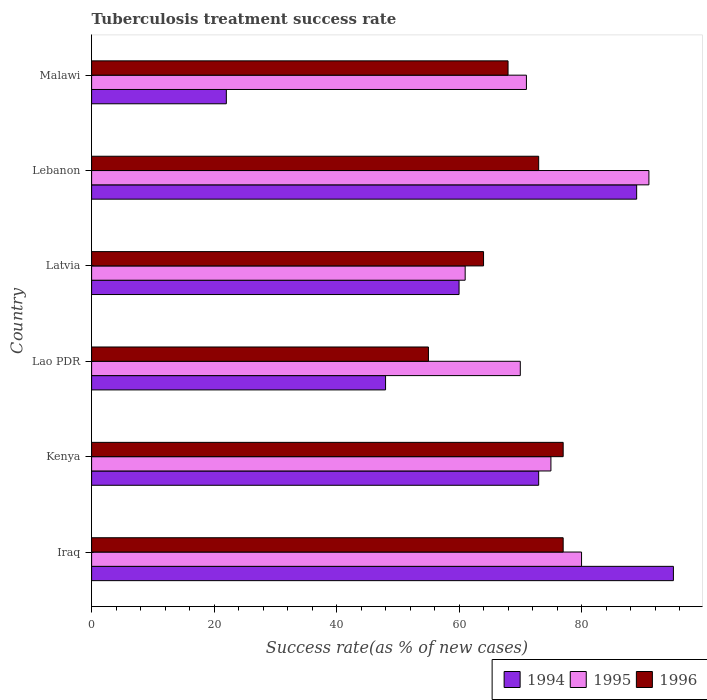How many different coloured bars are there?
Offer a very short reply. 3. How many bars are there on the 5th tick from the top?
Offer a terse response. 3. How many bars are there on the 2nd tick from the bottom?
Ensure brevity in your answer.  3. What is the label of the 5th group of bars from the top?
Give a very brief answer. Kenya. What is the tuberculosis treatment success rate in 1994 in Kenya?
Give a very brief answer. 73. Across all countries, what is the minimum tuberculosis treatment success rate in 1994?
Your answer should be compact. 22. In which country was the tuberculosis treatment success rate in 1995 maximum?
Offer a terse response. Lebanon. In which country was the tuberculosis treatment success rate in 1996 minimum?
Give a very brief answer. Lao PDR. What is the total tuberculosis treatment success rate in 1996 in the graph?
Offer a very short reply. 414. What is the difference between the tuberculosis treatment success rate in 1994 in Kenya and that in Latvia?
Keep it short and to the point. 13. What is the average tuberculosis treatment success rate in 1994 per country?
Your response must be concise. 64.5. What is the ratio of the tuberculosis treatment success rate in 1996 in Iraq to that in Latvia?
Your answer should be very brief. 1.2. In how many countries, is the tuberculosis treatment success rate in 1996 greater than the average tuberculosis treatment success rate in 1996 taken over all countries?
Make the answer very short. 3. Is the sum of the tuberculosis treatment success rate in 1996 in Lao PDR and Malawi greater than the maximum tuberculosis treatment success rate in 1995 across all countries?
Keep it short and to the point. Yes. What does the 2nd bar from the bottom in Kenya represents?
Ensure brevity in your answer.  1995. Is it the case that in every country, the sum of the tuberculosis treatment success rate in 1996 and tuberculosis treatment success rate in 1994 is greater than the tuberculosis treatment success rate in 1995?
Keep it short and to the point. Yes. How many bars are there?
Your answer should be compact. 18. What is the difference between two consecutive major ticks on the X-axis?
Provide a succinct answer. 20. Are the values on the major ticks of X-axis written in scientific E-notation?
Offer a terse response. No. Does the graph contain any zero values?
Provide a succinct answer. No. Where does the legend appear in the graph?
Give a very brief answer. Bottom right. How are the legend labels stacked?
Ensure brevity in your answer.  Horizontal. What is the title of the graph?
Provide a succinct answer. Tuberculosis treatment success rate. Does "1964" appear as one of the legend labels in the graph?
Your answer should be very brief. No. What is the label or title of the X-axis?
Your answer should be compact. Success rate(as % of new cases). What is the Success rate(as % of new cases) of 1995 in Iraq?
Provide a short and direct response. 80. What is the Success rate(as % of new cases) in 1995 in Kenya?
Your answer should be very brief. 75. What is the Success rate(as % of new cases) of 1994 in Lao PDR?
Offer a very short reply. 48. What is the Success rate(as % of new cases) in 1994 in Lebanon?
Give a very brief answer. 89. What is the Success rate(as % of new cases) in 1995 in Lebanon?
Your answer should be very brief. 91. What is the Success rate(as % of new cases) of 1994 in Malawi?
Your response must be concise. 22. What is the Success rate(as % of new cases) in 1995 in Malawi?
Make the answer very short. 71. What is the Success rate(as % of new cases) in 1996 in Malawi?
Keep it short and to the point. 68. Across all countries, what is the maximum Success rate(as % of new cases) of 1995?
Give a very brief answer. 91. Across all countries, what is the minimum Success rate(as % of new cases) in 1994?
Ensure brevity in your answer.  22. Across all countries, what is the minimum Success rate(as % of new cases) of 1996?
Give a very brief answer. 55. What is the total Success rate(as % of new cases) of 1994 in the graph?
Offer a very short reply. 387. What is the total Success rate(as % of new cases) of 1995 in the graph?
Offer a terse response. 448. What is the total Success rate(as % of new cases) in 1996 in the graph?
Keep it short and to the point. 414. What is the difference between the Success rate(as % of new cases) of 1994 in Iraq and that in Lao PDR?
Ensure brevity in your answer.  47. What is the difference between the Success rate(as % of new cases) in 1995 in Iraq and that in Lao PDR?
Your response must be concise. 10. What is the difference between the Success rate(as % of new cases) in 1995 in Iraq and that in Latvia?
Provide a short and direct response. 19. What is the difference between the Success rate(as % of new cases) of 1996 in Iraq and that in Latvia?
Offer a terse response. 13. What is the difference between the Success rate(as % of new cases) in 1994 in Iraq and that in Lebanon?
Your answer should be compact. 6. What is the difference between the Success rate(as % of new cases) in 1995 in Iraq and that in Malawi?
Offer a terse response. 9. What is the difference between the Success rate(as % of new cases) of 1996 in Iraq and that in Malawi?
Your answer should be very brief. 9. What is the difference between the Success rate(as % of new cases) of 1996 in Kenya and that in Lao PDR?
Your answer should be very brief. 22. What is the difference between the Success rate(as % of new cases) of 1994 in Kenya and that in Malawi?
Give a very brief answer. 51. What is the difference between the Success rate(as % of new cases) of 1995 in Kenya and that in Malawi?
Make the answer very short. 4. What is the difference between the Success rate(as % of new cases) of 1996 in Kenya and that in Malawi?
Ensure brevity in your answer.  9. What is the difference between the Success rate(as % of new cases) of 1994 in Lao PDR and that in Lebanon?
Give a very brief answer. -41. What is the difference between the Success rate(as % of new cases) in 1995 in Lao PDR and that in Lebanon?
Ensure brevity in your answer.  -21. What is the difference between the Success rate(as % of new cases) in 1996 in Lao PDR and that in Malawi?
Provide a short and direct response. -13. What is the difference between the Success rate(as % of new cases) of 1994 in Latvia and that in Lebanon?
Provide a short and direct response. -29. What is the difference between the Success rate(as % of new cases) of 1995 in Latvia and that in Lebanon?
Your answer should be very brief. -30. What is the difference between the Success rate(as % of new cases) in 1994 in Latvia and that in Malawi?
Ensure brevity in your answer.  38. What is the difference between the Success rate(as % of new cases) in 1996 in Latvia and that in Malawi?
Make the answer very short. -4. What is the difference between the Success rate(as % of new cases) of 1994 in Lebanon and that in Malawi?
Ensure brevity in your answer.  67. What is the difference between the Success rate(as % of new cases) of 1995 in Iraq and the Success rate(as % of new cases) of 1996 in Kenya?
Your answer should be compact. 3. What is the difference between the Success rate(as % of new cases) in 1994 in Iraq and the Success rate(as % of new cases) in 1995 in Lao PDR?
Offer a terse response. 25. What is the difference between the Success rate(as % of new cases) of 1994 in Iraq and the Success rate(as % of new cases) of 1996 in Lao PDR?
Offer a terse response. 40. What is the difference between the Success rate(as % of new cases) in 1995 in Iraq and the Success rate(as % of new cases) in 1996 in Latvia?
Your response must be concise. 16. What is the difference between the Success rate(as % of new cases) of 1994 in Iraq and the Success rate(as % of new cases) of 1995 in Lebanon?
Your answer should be very brief. 4. What is the difference between the Success rate(as % of new cases) in 1995 in Iraq and the Success rate(as % of new cases) in 1996 in Lebanon?
Give a very brief answer. 7. What is the difference between the Success rate(as % of new cases) in 1994 in Iraq and the Success rate(as % of new cases) in 1995 in Malawi?
Your response must be concise. 24. What is the difference between the Success rate(as % of new cases) of 1995 in Iraq and the Success rate(as % of new cases) of 1996 in Malawi?
Offer a terse response. 12. What is the difference between the Success rate(as % of new cases) of 1994 in Kenya and the Success rate(as % of new cases) of 1995 in Lao PDR?
Ensure brevity in your answer.  3. What is the difference between the Success rate(as % of new cases) in 1994 in Kenya and the Success rate(as % of new cases) in 1996 in Lao PDR?
Offer a terse response. 18. What is the difference between the Success rate(as % of new cases) in 1995 in Kenya and the Success rate(as % of new cases) in 1996 in Latvia?
Make the answer very short. 11. What is the difference between the Success rate(as % of new cases) in 1994 in Kenya and the Success rate(as % of new cases) in 1996 in Lebanon?
Ensure brevity in your answer.  0. What is the difference between the Success rate(as % of new cases) in 1994 in Kenya and the Success rate(as % of new cases) in 1995 in Malawi?
Make the answer very short. 2. What is the difference between the Success rate(as % of new cases) of 1995 in Kenya and the Success rate(as % of new cases) of 1996 in Malawi?
Your answer should be compact. 7. What is the difference between the Success rate(as % of new cases) in 1994 in Lao PDR and the Success rate(as % of new cases) in 1995 in Latvia?
Make the answer very short. -13. What is the difference between the Success rate(as % of new cases) of 1995 in Lao PDR and the Success rate(as % of new cases) of 1996 in Latvia?
Offer a terse response. 6. What is the difference between the Success rate(as % of new cases) in 1994 in Lao PDR and the Success rate(as % of new cases) in 1995 in Lebanon?
Give a very brief answer. -43. What is the difference between the Success rate(as % of new cases) of 1994 in Lao PDR and the Success rate(as % of new cases) of 1996 in Lebanon?
Provide a succinct answer. -25. What is the difference between the Success rate(as % of new cases) in 1994 in Lao PDR and the Success rate(as % of new cases) in 1995 in Malawi?
Provide a succinct answer. -23. What is the difference between the Success rate(as % of new cases) in 1995 in Lao PDR and the Success rate(as % of new cases) in 1996 in Malawi?
Provide a short and direct response. 2. What is the difference between the Success rate(as % of new cases) in 1994 in Latvia and the Success rate(as % of new cases) in 1995 in Lebanon?
Your response must be concise. -31. What is the difference between the Success rate(as % of new cases) of 1994 in Latvia and the Success rate(as % of new cases) of 1996 in Lebanon?
Make the answer very short. -13. What is the difference between the Success rate(as % of new cases) of 1995 in Latvia and the Success rate(as % of new cases) of 1996 in Malawi?
Provide a short and direct response. -7. What is the difference between the Success rate(as % of new cases) in 1994 in Lebanon and the Success rate(as % of new cases) in 1995 in Malawi?
Your answer should be compact. 18. What is the difference between the Success rate(as % of new cases) of 1994 in Lebanon and the Success rate(as % of new cases) of 1996 in Malawi?
Give a very brief answer. 21. What is the average Success rate(as % of new cases) in 1994 per country?
Make the answer very short. 64.5. What is the average Success rate(as % of new cases) in 1995 per country?
Provide a succinct answer. 74.67. What is the average Success rate(as % of new cases) in 1996 per country?
Ensure brevity in your answer.  69. What is the difference between the Success rate(as % of new cases) of 1995 and Success rate(as % of new cases) of 1996 in Iraq?
Provide a succinct answer. 3. What is the difference between the Success rate(as % of new cases) of 1994 and Success rate(as % of new cases) of 1995 in Kenya?
Your answer should be compact. -2. What is the difference between the Success rate(as % of new cases) in 1994 and Success rate(as % of new cases) in 1996 in Kenya?
Keep it short and to the point. -4. What is the difference between the Success rate(as % of new cases) in 1995 and Success rate(as % of new cases) in 1996 in Kenya?
Your answer should be compact. -2. What is the difference between the Success rate(as % of new cases) of 1994 and Success rate(as % of new cases) of 1995 in Lao PDR?
Your response must be concise. -22. What is the difference between the Success rate(as % of new cases) in 1995 and Success rate(as % of new cases) in 1996 in Lao PDR?
Give a very brief answer. 15. What is the difference between the Success rate(as % of new cases) in 1994 and Success rate(as % of new cases) in 1995 in Latvia?
Your answer should be very brief. -1. What is the difference between the Success rate(as % of new cases) of 1994 and Success rate(as % of new cases) of 1996 in Latvia?
Offer a terse response. -4. What is the difference between the Success rate(as % of new cases) in 1994 and Success rate(as % of new cases) in 1996 in Lebanon?
Provide a short and direct response. 16. What is the difference between the Success rate(as % of new cases) of 1995 and Success rate(as % of new cases) of 1996 in Lebanon?
Make the answer very short. 18. What is the difference between the Success rate(as % of new cases) in 1994 and Success rate(as % of new cases) in 1995 in Malawi?
Ensure brevity in your answer.  -49. What is the difference between the Success rate(as % of new cases) in 1994 and Success rate(as % of new cases) in 1996 in Malawi?
Ensure brevity in your answer.  -46. What is the difference between the Success rate(as % of new cases) in 1995 and Success rate(as % of new cases) in 1996 in Malawi?
Offer a terse response. 3. What is the ratio of the Success rate(as % of new cases) in 1994 in Iraq to that in Kenya?
Provide a short and direct response. 1.3. What is the ratio of the Success rate(as % of new cases) of 1995 in Iraq to that in Kenya?
Provide a succinct answer. 1.07. What is the ratio of the Success rate(as % of new cases) of 1994 in Iraq to that in Lao PDR?
Provide a succinct answer. 1.98. What is the ratio of the Success rate(as % of new cases) of 1994 in Iraq to that in Latvia?
Provide a succinct answer. 1.58. What is the ratio of the Success rate(as % of new cases) in 1995 in Iraq to that in Latvia?
Your response must be concise. 1.31. What is the ratio of the Success rate(as % of new cases) in 1996 in Iraq to that in Latvia?
Your answer should be very brief. 1.2. What is the ratio of the Success rate(as % of new cases) of 1994 in Iraq to that in Lebanon?
Provide a succinct answer. 1.07. What is the ratio of the Success rate(as % of new cases) in 1995 in Iraq to that in Lebanon?
Your answer should be very brief. 0.88. What is the ratio of the Success rate(as % of new cases) in 1996 in Iraq to that in Lebanon?
Make the answer very short. 1.05. What is the ratio of the Success rate(as % of new cases) of 1994 in Iraq to that in Malawi?
Offer a very short reply. 4.32. What is the ratio of the Success rate(as % of new cases) in 1995 in Iraq to that in Malawi?
Give a very brief answer. 1.13. What is the ratio of the Success rate(as % of new cases) of 1996 in Iraq to that in Malawi?
Your answer should be compact. 1.13. What is the ratio of the Success rate(as % of new cases) in 1994 in Kenya to that in Lao PDR?
Provide a short and direct response. 1.52. What is the ratio of the Success rate(as % of new cases) in 1995 in Kenya to that in Lao PDR?
Your response must be concise. 1.07. What is the ratio of the Success rate(as % of new cases) in 1994 in Kenya to that in Latvia?
Offer a terse response. 1.22. What is the ratio of the Success rate(as % of new cases) in 1995 in Kenya to that in Latvia?
Provide a short and direct response. 1.23. What is the ratio of the Success rate(as % of new cases) in 1996 in Kenya to that in Latvia?
Offer a terse response. 1.2. What is the ratio of the Success rate(as % of new cases) in 1994 in Kenya to that in Lebanon?
Give a very brief answer. 0.82. What is the ratio of the Success rate(as % of new cases) of 1995 in Kenya to that in Lebanon?
Your answer should be very brief. 0.82. What is the ratio of the Success rate(as % of new cases) of 1996 in Kenya to that in Lebanon?
Give a very brief answer. 1.05. What is the ratio of the Success rate(as % of new cases) of 1994 in Kenya to that in Malawi?
Your response must be concise. 3.32. What is the ratio of the Success rate(as % of new cases) in 1995 in Kenya to that in Malawi?
Offer a terse response. 1.06. What is the ratio of the Success rate(as % of new cases) in 1996 in Kenya to that in Malawi?
Your answer should be very brief. 1.13. What is the ratio of the Success rate(as % of new cases) of 1994 in Lao PDR to that in Latvia?
Offer a terse response. 0.8. What is the ratio of the Success rate(as % of new cases) of 1995 in Lao PDR to that in Latvia?
Make the answer very short. 1.15. What is the ratio of the Success rate(as % of new cases) of 1996 in Lao PDR to that in Latvia?
Offer a very short reply. 0.86. What is the ratio of the Success rate(as % of new cases) of 1994 in Lao PDR to that in Lebanon?
Your answer should be very brief. 0.54. What is the ratio of the Success rate(as % of new cases) of 1995 in Lao PDR to that in Lebanon?
Give a very brief answer. 0.77. What is the ratio of the Success rate(as % of new cases) of 1996 in Lao PDR to that in Lebanon?
Provide a short and direct response. 0.75. What is the ratio of the Success rate(as % of new cases) of 1994 in Lao PDR to that in Malawi?
Provide a short and direct response. 2.18. What is the ratio of the Success rate(as % of new cases) of 1995 in Lao PDR to that in Malawi?
Offer a very short reply. 0.99. What is the ratio of the Success rate(as % of new cases) in 1996 in Lao PDR to that in Malawi?
Offer a terse response. 0.81. What is the ratio of the Success rate(as % of new cases) of 1994 in Latvia to that in Lebanon?
Ensure brevity in your answer.  0.67. What is the ratio of the Success rate(as % of new cases) of 1995 in Latvia to that in Lebanon?
Your answer should be very brief. 0.67. What is the ratio of the Success rate(as % of new cases) in 1996 in Latvia to that in Lebanon?
Give a very brief answer. 0.88. What is the ratio of the Success rate(as % of new cases) of 1994 in Latvia to that in Malawi?
Offer a terse response. 2.73. What is the ratio of the Success rate(as % of new cases) in 1995 in Latvia to that in Malawi?
Offer a very short reply. 0.86. What is the ratio of the Success rate(as % of new cases) of 1994 in Lebanon to that in Malawi?
Your answer should be very brief. 4.05. What is the ratio of the Success rate(as % of new cases) of 1995 in Lebanon to that in Malawi?
Provide a succinct answer. 1.28. What is the ratio of the Success rate(as % of new cases) of 1996 in Lebanon to that in Malawi?
Ensure brevity in your answer.  1.07. What is the difference between the highest and the second highest Success rate(as % of new cases) of 1994?
Offer a very short reply. 6. What is the difference between the highest and the second highest Success rate(as % of new cases) in 1995?
Your answer should be very brief. 11. What is the difference between the highest and the second highest Success rate(as % of new cases) of 1996?
Provide a succinct answer. 0. What is the difference between the highest and the lowest Success rate(as % of new cases) of 1995?
Provide a short and direct response. 30. What is the difference between the highest and the lowest Success rate(as % of new cases) of 1996?
Your response must be concise. 22. 